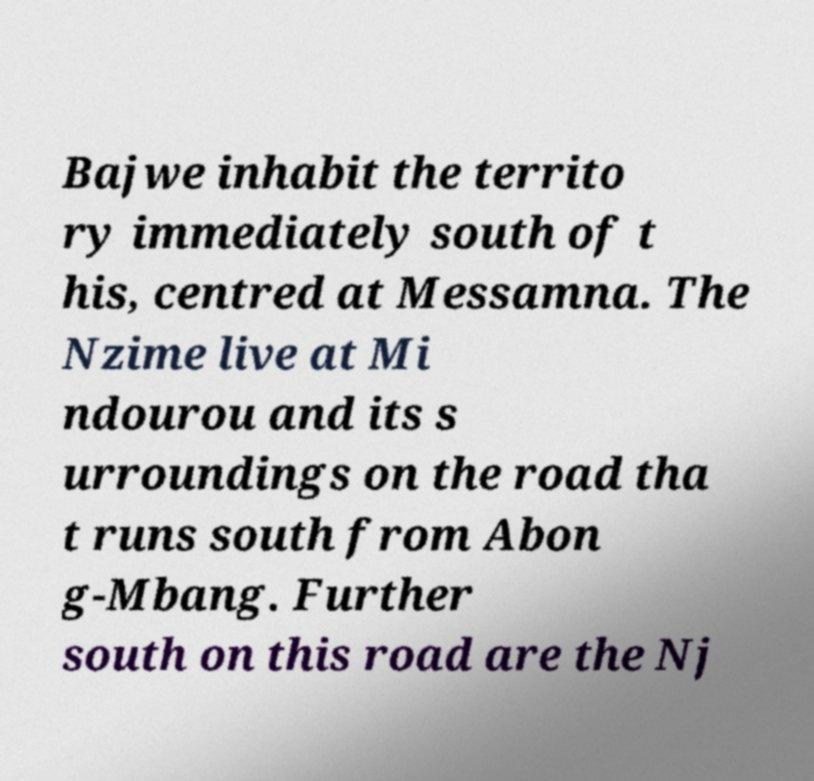For documentation purposes, I need the text within this image transcribed. Could you provide that? Bajwe inhabit the territo ry immediately south of t his, centred at Messamna. The Nzime live at Mi ndourou and its s urroundings on the road tha t runs south from Abon g-Mbang. Further south on this road are the Nj 